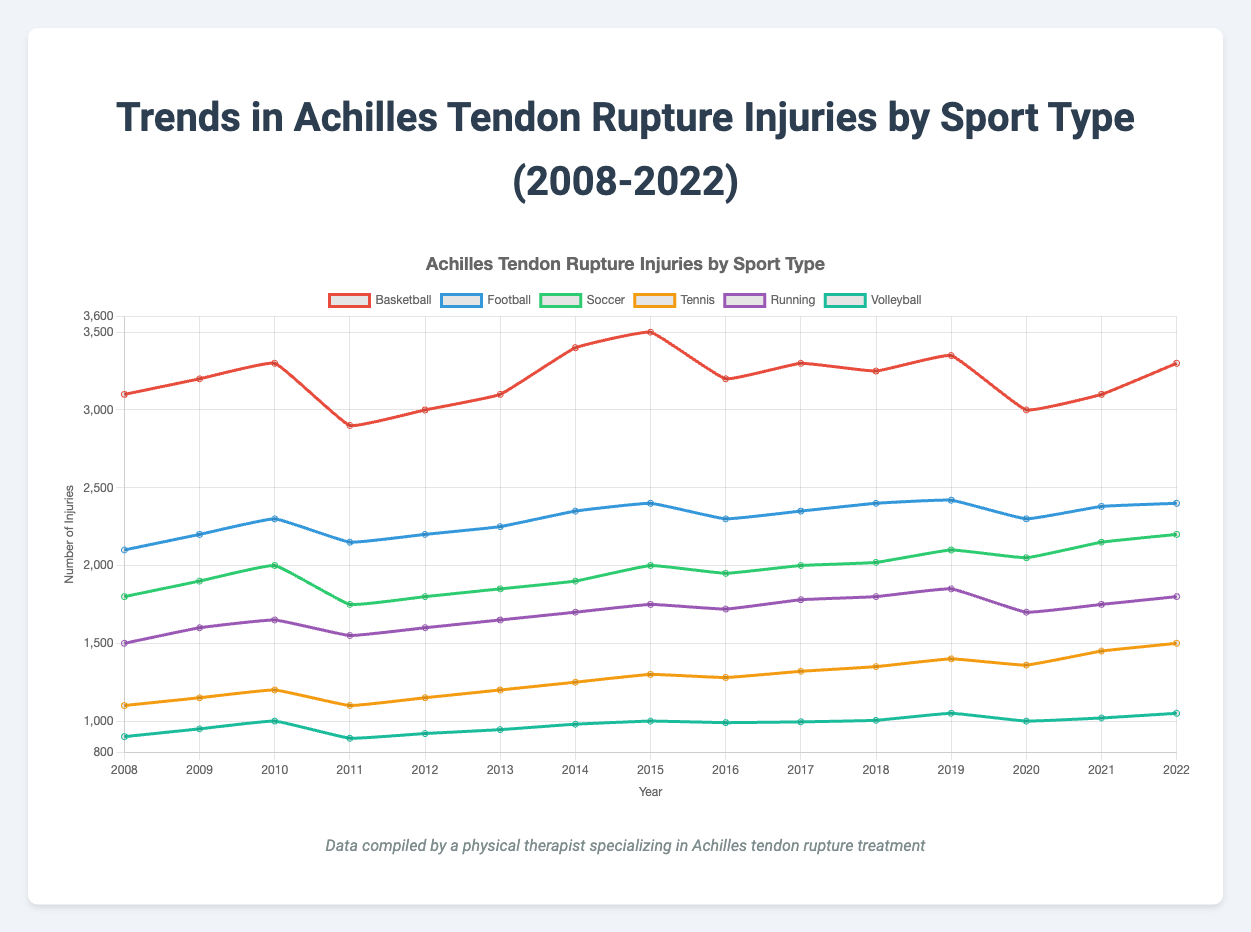Which sport had the highest number of Achilles tendon rupture injuries in 2022? Look at the year 2022 on the x-axis and check the corresponding values for each sport. Basketball has the highest value at 3300.
Answer: Basketball Between 2008 and 2022, which sport had the smallest increase in the number of Achilles tendon rupture injuries? Calculate the difference between the values in 2022 and 2008 for each sport. Volleyball had the smallest increase (150 injuries from 900 to 1050).
Answer: Volleyball Which two sports had the closest number of injuries in 2019? Look at the values for each sport in 2019 and compare them. Football and Soccer had close numbers of injuries (2420 and 2100 respectively).
Answer: Football and Soccer What is the trend for Running injuries from 2015 to 2020? Observe the data points for Running from 2015 to 2020. The trend is an increase from 1750 to 1700 with minor fluctuations.
Answer: Increasing In which year did Basketball see the largest decrease in injuries compared to the previous year? Check the differences between consecutive years for Basketball. The largest decrease occurred between 2010 and 2011 (400 injuries, from 3300 to 2900).
Answer: 2011 Which sport had the most consistent (least fluctuating) number of injuries over the 15 years? Examine the fluctuation in the lines for each sport. Football has the most consistent number of injuries with fewer fluctuations.
Answer: Football How did Soccer injuries change from 2020 to 2022? Observe the Soccer line from 2020 to 2022. The injuries increased from 2050 to 2200.
Answer: Increased Which sport had a notable peak in injuries in a single year, and what was the year? Look for sharp peaks in the lines. Basketball peaked in 2015 with 3500 injuries.
Answer: Basketball, 2015 What is the difference between the number of injuries in Tennis and Volleyball in 2020? Subtract the value for Volleyball from the value for Tennis in 2020 (1360 - 1000 = 360).
Answer: 360 Which sport showed a declining trend in injuries in 2020 and then an increasing trend afterward? Identify the lines showing a decrease in 2020 followed by an increase. Soccer decreased in 2020 (from 2100 in 2019 to 2050) but increased afterward.
Answer: Soccer 